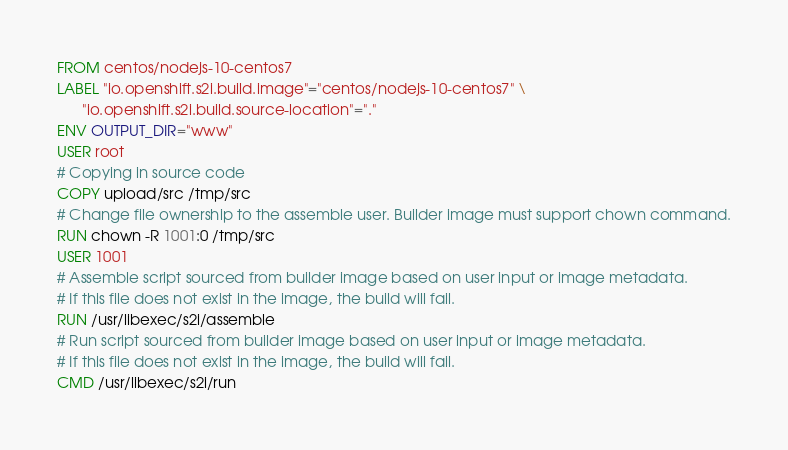<code> <loc_0><loc_0><loc_500><loc_500><_Dockerfile_>FROM centos/nodejs-10-centos7
LABEL "io.openshift.s2i.build.image"="centos/nodejs-10-centos7" \
      "io.openshift.s2i.build.source-location"="."
ENV OUTPUT_DIR="www"
USER root
# Copying in source code
COPY upload/src /tmp/src
# Change file ownership to the assemble user. Builder image must support chown command.
RUN chown -R 1001:0 /tmp/src
USER 1001
# Assemble script sourced from builder image based on user input or image metadata.
# If this file does not exist in the image, the build will fail.
RUN /usr/libexec/s2i/assemble
# Run script sourced from builder image based on user input or image metadata.
# If this file does not exist in the image, the build will fail.
CMD /usr/libexec/s2i/run
</code> 